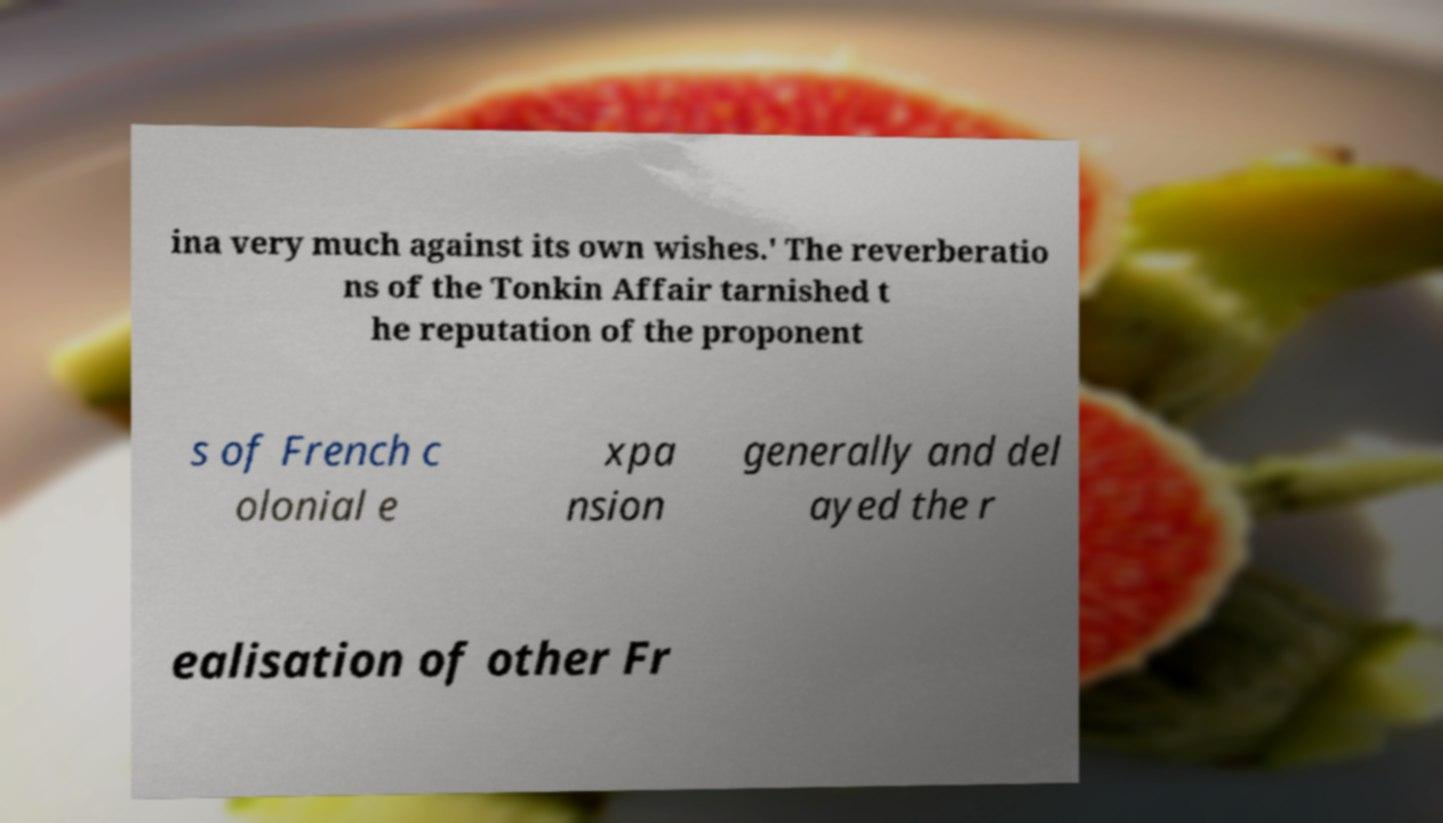Can you read and provide the text displayed in the image?This photo seems to have some interesting text. Can you extract and type it out for me? ina very much against its own wishes.' The reverberatio ns of the Tonkin Affair tarnished t he reputation of the proponent s of French c olonial e xpa nsion generally and del ayed the r ealisation of other Fr 